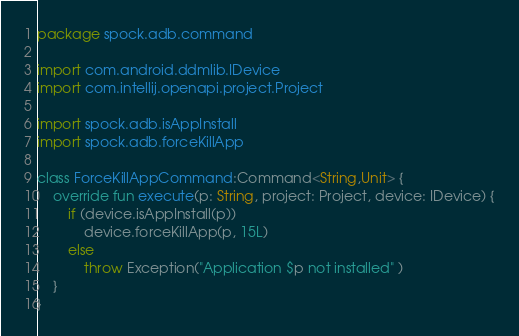<code> <loc_0><loc_0><loc_500><loc_500><_Kotlin_>package spock.adb.command

import com.android.ddmlib.IDevice
import com.intellij.openapi.project.Project

import spock.adb.isAppInstall
import spock.adb.forceKillApp

class ForceKillAppCommand:Command<String,Unit> {
    override fun execute(p: String, project: Project, device: IDevice) {
        if (device.isAppInstall(p))
            device.forceKillApp(p, 15L)
        else
            throw Exception("Application $p not installed" )
    }
}
</code> 